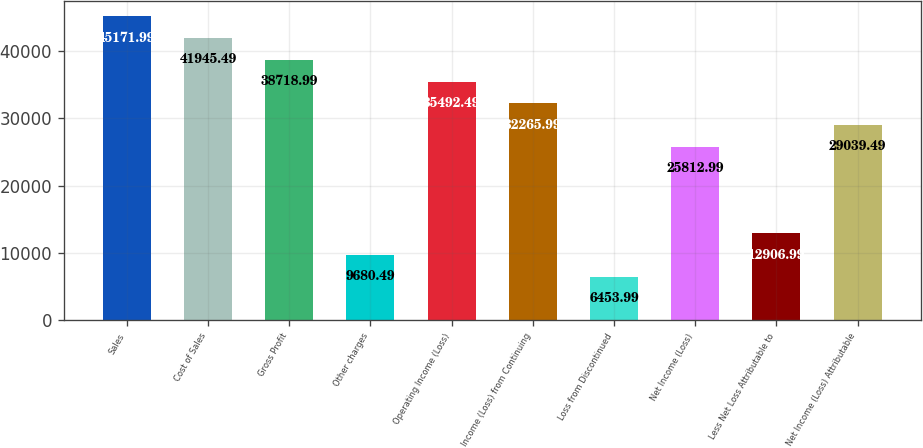Convert chart. <chart><loc_0><loc_0><loc_500><loc_500><bar_chart><fcel>Sales<fcel>Cost of Sales<fcel>Gross Profit<fcel>Other charges<fcel>Operating Income (Loss)<fcel>Income (Loss) from Continuing<fcel>Loss from Discontinued<fcel>Net Income (Loss)<fcel>Less Net Loss Attributable to<fcel>Net Income (Loss) Attributable<nl><fcel>45172<fcel>41945.5<fcel>38719<fcel>9680.49<fcel>35492.5<fcel>32266<fcel>6453.99<fcel>25813<fcel>12907<fcel>29039.5<nl></chart> 